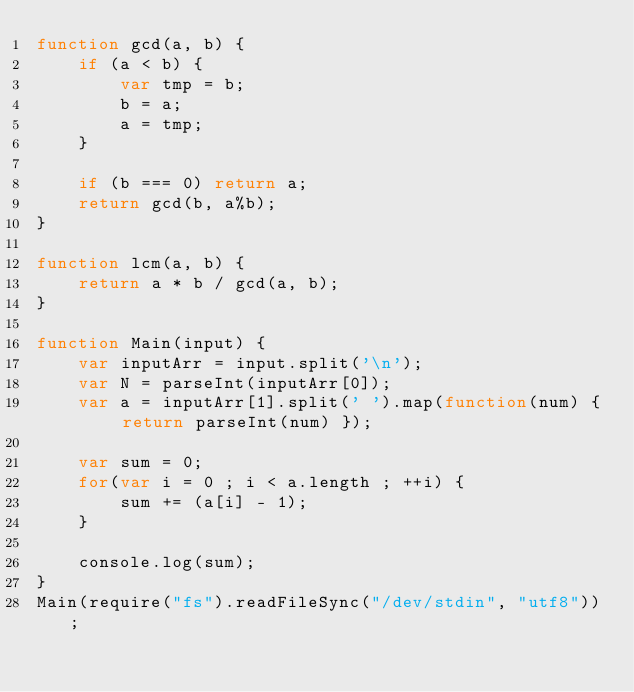<code> <loc_0><loc_0><loc_500><loc_500><_JavaScript_>function gcd(a, b) {
    if (a < b) {
        var tmp = b;
        b = a;
        a = tmp;
    }

    if (b === 0) return a;
    return gcd(b, a%b);
}

function lcm(a, b) {
    return a * b / gcd(a, b);
}

function Main(input) {
    var inputArr = input.split('\n');
    var N = parseInt(inputArr[0]);
    var a = inputArr[1].split(' ').map(function(num) { return parseInt(num) });

    var sum = 0;
    for(var i = 0 ; i < a.length ; ++i) {
        sum += (a[i] - 1);
    }

    console.log(sum);
}
Main(require("fs").readFileSync("/dev/stdin", "utf8"));</code> 